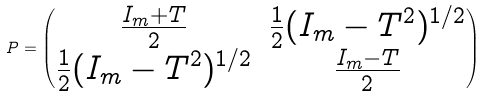<formula> <loc_0><loc_0><loc_500><loc_500>P = \begin{pmatrix} \frac { I _ { m } + T } { 2 } & \frac { 1 } { 2 } ( I _ { m } - T ^ { 2 } ) ^ { 1 / 2 } \\ \frac { 1 } { 2 } ( I _ { m } - T ^ { 2 } ) ^ { 1 / 2 } & \frac { I _ { m } - T } { 2 } \end{pmatrix}</formula> 